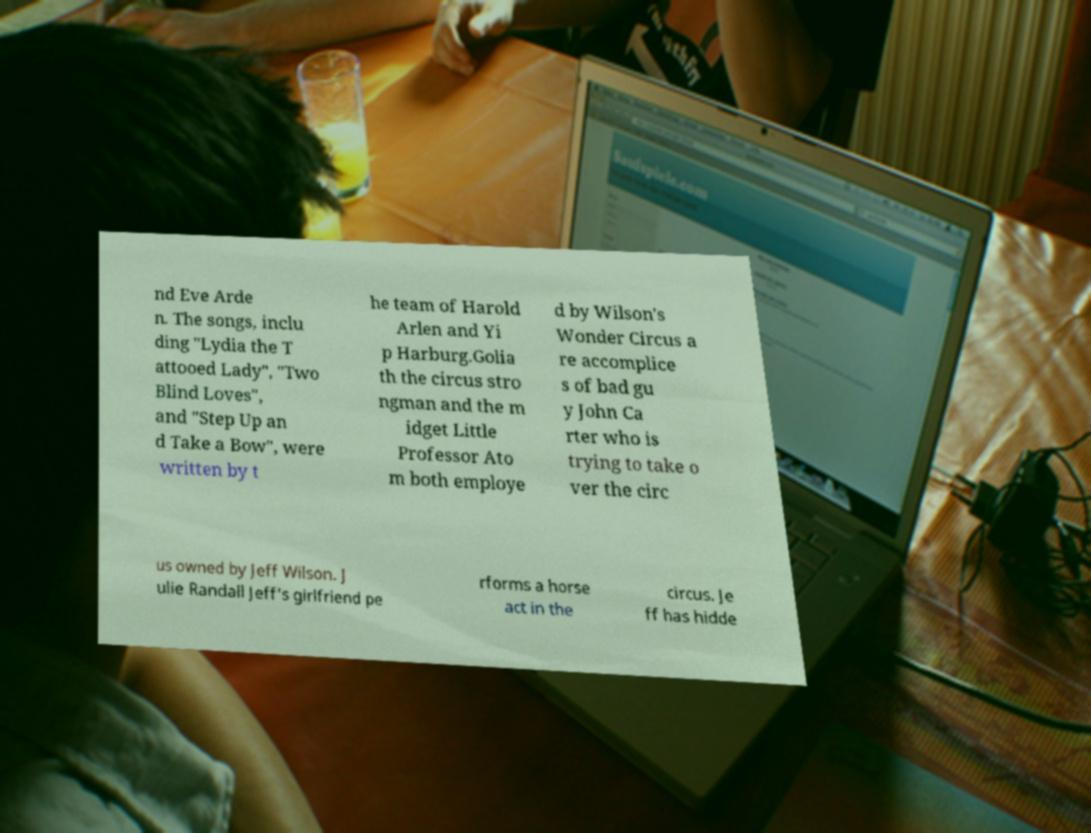Could you assist in decoding the text presented in this image and type it out clearly? nd Eve Arde n. The songs, inclu ding "Lydia the T attooed Lady", "Two Blind Loves", and "Step Up an d Take a Bow", were written by t he team of Harold Arlen and Yi p Harburg.Golia th the circus stro ngman and the m idget Little Professor Ato m both employe d by Wilson's Wonder Circus a re accomplice s of bad gu y John Ca rter who is trying to take o ver the circ us owned by Jeff Wilson. J ulie Randall Jeff's girlfriend pe rforms a horse act in the circus. Je ff has hidde 